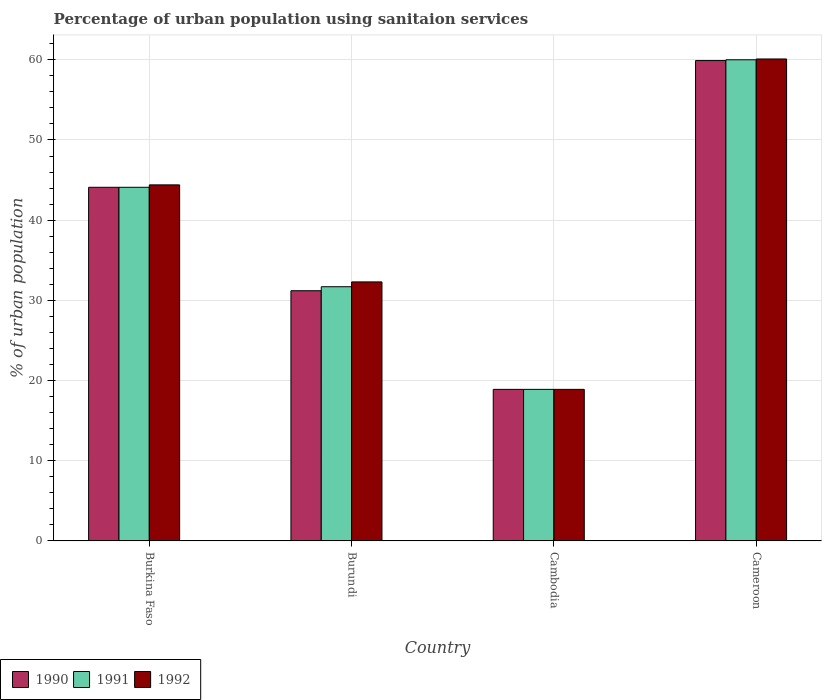Are the number of bars per tick equal to the number of legend labels?
Ensure brevity in your answer.  Yes. Are the number of bars on each tick of the X-axis equal?
Provide a short and direct response. Yes. How many bars are there on the 1st tick from the left?
Ensure brevity in your answer.  3. What is the label of the 1st group of bars from the left?
Your response must be concise. Burkina Faso. In how many cases, is the number of bars for a given country not equal to the number of legend labels?
Make the answer very short. 0. What is the percentage of urban population using sanitaion services in 1991 in Cameroon?
Your answer should be very brief. 60. Across all countries, what is the maximum percentage of urban population using sanitaion services in 1990?
Provide a succinct answer. 59.9. Across all countries, what is the minimum percentage of urban population using sanitaion services in 1990?
Offer a very short reply. 18.9. In which country was the percentage of urban population using sanitaion services in 1991 maximum?
Offer a very short reply. Cameroon. In which country was the percentage of urban population using sanitaion services in 1991 minimum?
Make the answer very short. Cambodia. What is the total percentage of urban population using sanitaion services in 1992 in the graph?
Ensure brevity in your answer.  155.7. What is the difference between the percentage of urban population using sanitaion services in 1992 in Burkina Faso and that in Cameroon?
Your answer should be very brief. -15.7. What is the difference between the percentage of urban population using sanitaion services in 1992 in Cameroon and the percentage of urban population using sanitaion services in 1990 in Burundi?
Offer a very short reply. 28.9. What is the average percentage of urban population using sanitaion services in 1990 per country?
Your answer should be very brief. 38.52. What is the difference between the percentage of urban population using sanitaion services of/in 1991 and percentage of urban population using sanitaion services of/in 1992 in Cambodia?
Offer a terse response. 0. What is the ratio of the percentage of urban population using sanitaion services in 1990 in Burkina Faso to that in Cambodia?
Your response must be concise. 2.33. Is the percentage of urban population using sanitaion services in 1991 in Burkina Faso less than that in Burundi?
Your response must be concise. No. What is the difference between the highest and the second highest percentage of urban population using sanitaion services in 1991?
Ensure brevity in your answer.  15.9. What is the difference between the highest and the lowest percentage of urban population using sanitaion services in 1991?
Your answer should be compact. 41.1. Is the sum of the percentage of urban population using sanitaion services in 1991 in Burkina Faso and Cambodia greater than the maximum percentage of urban population using sanitaion services in 1992 across all countries?
Provide a short and direct response. Yes. What does the 3rd bar from the left in Burkina Faso represents?
Your response must be concise. 1992. How many bars are there?
Offer a very short reply. 12. How many countries are there in the graph?
Offer a very short reply. 4. Are the values on the major ticks of Y-axis written in scientific E-notation?
Offer a very short reply. No. Does the graph contain any zero values?
Ensure brevity in your answer.  No. Does the graph contain grids?
Your answer should be compact. Yes. How many legend labels are there?
Keep it short and to the point. 3. How are the legend labels stacked?
Give a very brief answer. Horizontal. What is the title of the graph?
Keep it short and to the point. Percentage of urban population using sanitaion services. What is the label or title of the Y-axis?
Make the answer very short. % of urban population. What is the % of urban population in 1990 in Burkina Faso?
Ensure brevity in your answer.  44.1. What is the % of urban population in 1991 in Burkina Faso?
Your answer should be very brief. 44.1. What is the % of urban population of 1992 in Burkina Faso?
Provide a succinct answer. 44.4. What is the % of urban population of 1990 in Burundi?
Provide a succinct answer. 31.2. What is the % of urban population in 1991 in Burundi?
Make the answer very short. 31.7. What is the % of urban population of 1992 in Burundi?
Provide a succinct answer. 32.3. What is the % of urban population of 1990 in Cameroon?
Ensure brevity in your answer.  59.9. What is the % of urban population in 1992 in Cameroon?
Offer a terse response. 60.1. Across all countries, what is the maximum % of urban population of 1990?
Keep it short and to the point. 59.9. Across all countries, what is the maximum % of urban population in 1991?
Your response must be concise. 60. Across all countries, what is the maximum % of urban population of 1992?
Your answer should be very brief. 60.1. Across all countries, what is the minimum % of urban population of 1990?
Provide a succinct answer. 18.9. Across all countries, what is the minimum % of urban population in 1992?
Keep it short and to the point. 18.9. What is the total % of urban population in 1990 in the graph?
Ensure brevity in your answer.  154.1. What is the total % of urban population of 1991 in the graph?
Give a very brief answer. 154.7. What is the total % of urban population of 1992 in the graph?
Keep it short and to the point. 155.7. What is the difference between the % of urban population in 1990 in Burkina Faso and that in Burundi?
Offer a very short reply. 12.9. What is the difference between the % of urban population in 1991 in Burkina Faso and that in Burundi?
Give a very brief answer. 12.4. What is the difference between the % of urban population of 1992 in Burkina Faso and that in Burundi?
Your answer should be very brief. 12.1. What is the difference between the % of urban population of 1990 in Burkina Faso and that in Cambodia?
Ensure brevity in your answer.  25.2. What is the difference between the % of urban population in 1991 in Burkina Faso and that in Cambodia?
Ensure brevity in your answer.  25.2. What is the difference between the % of urban population of 1992 in Burkina Faso and that in Cambodia?
Make the answer very short. 25.5. What is the difference between the % of urban population in 1990 in Burkina Faso and that in Cameroon?
Ensure brevity in your answer.  -15.8. What is the difference between the % of urban population in 1991 in Burkina Faso and that in Cameroon?
Provide a short and direct response. -15.9. What is the difference between the % of urban population in 1992 in Burkina Faso and that in Cameroon?
Make the answer very short. -15.7. What is the difference between the % of urban population of 1990 in Burundi and that in Cameroon?
Provide a succinct answer. -28.7. What is the difference between the % of urban population in 1991 in Burundi and that in Cameroon?
Your response must be concise. -28.3. What is the difference between the % of urban population of 1992 in Burundi and that in Cameroon?
Ensure brevity in your answer.  -27.8. What is the difference between the % of urban population in 1990 in Cambodia and that in Cameroon?
Offer a very short reply. -41. What is the difference between the % of urban population in 1991 in Cambodia and that in Cameroon?
Provide a succinct answer. -41.1. What is the difference between the % of urban population of 1992 in Cambodia and that in Cameroon?
Your answer should be very brief. -41.2. What is the difference between the % of urban population in 1990 in Burkina Faso and the % of urban population in 1991 in Burundi?
Offer a very short reply. 12.4. What is the difference between the % of urban population in 1990 in Burkina Faso and the % of urban population in 1991 in Cambodia?
Give a very brief answer. 25.2. What is the difference between the % of urban population of 1990 in Burkina Faso and the % of urban population of 1992 in Cambodia?
Provide a succinct answer. 25.2. What is the difference between the % of urban population in 1991 in Burkina Faso and the % of urban population in 1992 in Cambodia?
Offer a very short reply. 25.2. What is the difference between the % of urban population of 1990 in Burkina Faso and the % of urban population of 1991 in Cameroon?
Provide a short and direct response. -15.9. What is the difference between the % of urban population in 1990 in Burkina Faso and the % of urban population in 1992 in Cameroon?
Offer a very short reply. -16. What is the difference between the % of urban population in 1990 in Burundi and the % of urban population in 1991 in Cambodia?
Offer a very short reply. 12.3. What is the difference between the % of urban population of 1991 in Burundi and the % of urban population of 1992 in Cambodia?
Your response must be concise. 12.8. What is the difference between the % of urban population in 1990 in Burundi and the % of urban population in 1991 in Cameroon?
Your answer should be compact. -28.8. What is the difference between the % of urban population of 1990 in Burundi and the % of urban population of 1992 in Cameroon?
Keep it short and to the point. -28.9. What is the difference between the % of urban population in 1991 in Burundi and the % of urban population in 1992 in Cameroon?
Your answer should be very brief. -28.4. What is the difference between the % of urban population in 1990 in Cambodia and the % of urban population in 1991 in Cameroon?
Make the answer very short. -41.1. What is the difference between the % of urban population of 1990 in Cambodia and the % of urban population of 1992 in Cameroon?
Your response must be concise. -41.2. What is the difference between the % of urban population of 1991 in Cambodia and the % of urban population of 1992 in Cameroon?
Offer a terse response. -41.2. What is the average % of urban population in 1990 per country?
Your answer should be very brief. 38.52. What is the average % of urban population of 1991 per country?
Offer a very short reply. 38.67. What is the average % of urban population of 1992 per country?
Offer a very short reply. 38.92. What is the difference between the % of urban population of 1990 and % of urban population of 1991 in Burundi?
Offer a very short reply. -0.5. What is the difference between the % of urban population in 1990 and % of urban population in 1992 in Burundi?
Offer a very short reply. -1.1. What is the difference between the % of urban population of 1990 and % of urban population of 1991 in Cameroon?
Keep it short and to the point. -0.1. What is the difference between the % of urban population of 1990 and % of urban population of 1992 in Cameroon?
Your answer should be very brief. -0.2. What is the difference between the % of urban population in 1991 and % of urban population in 1992 in Cameroon?
Your response must be concise. -0.1. What is the ratio of the % of urban population of 1990 in Burkina Faso to that in Burundi?
Give a very brief answer. 1.41. What is the ratio of the % of urban population in 1991 in Burkina Faso to that in Burundi?
Your answer should be very brief. 1.39. What is the ratio of the % of urban population in 1992 in Burkina Faso to that in Burundi?
Provide a succinct answer. 1.37. What is the ratio of the % of urban population of 1990 in Burkina Faso to that in Cambodia?
Provide a succinct answer. 2.33. What is the ratio of the % of urban population of 1991 in Burkina Faso to that in Cambodia?
Ensure brevity in your answer.  2.33. What is the ratio of the % of urban population of 1992 in Burkina Faso to that in Cambodia?
Offer a very short reply. 2.35. What is the ratio of the % of urban population in 1990 in Burkina Faso to that in Cameroon?
Give a very brief answer. 0.74. What is the ratio of the % of urban population in 1991 in Burkina Faso to that in Cameroon?
Your answer should be compact. 0.73. What is the ratio of the % of urban population of 1992 in Burkina Faso to that in Cameroon?
Offer a very short reply. 0.74. What is the ratio of the % of urban population in 1990 in Burundi to that in Cambodia?
Provide a short and direct response. 1.65. What is the ratio of the % of urban population of 1991 in Burundi to that in Cambodia?
Your response must be concise. 1.68. What is the ratio of the % of urban population in 1992 in Burundi to that in Cambodia?
Provide a succinct answer. 1.71. What is the ratio of the % of urban population in 1990 in Burundi to that in Cameroon?
Keep it short and to the point. 0.52. What is the ratio of the % of urban population in 1991 in Burundi to that in Cameroon?
Provide a short and direct response. 0.53. What is the ratio of the % of urban population of 1992 in Burundi to that in Cameroon?
Give a very brief answer. 0.54. What is the ratio of the % of urban population in 1990 in Cambodia to that in Cameroon?
Your answer should be compact. 0.32. What is the ratio of the % of urban population of 1991 in Cambodia to that in Cameroon?
Ensure brevity in your answer.  0.32. What is the ratio of the % of urban population in 1992 in Cambodia to that in Cameroon?
Ensure brevity in your answer.  0.31. What is the difference between the highest and the second highest % of urban population of 1990?
Offer a very short reply. 15.8. What is the difference between the highest and the second highest % of urban population of 1991?
Offer a very short reply. 15.9. What is the difference between the highest and the lowest % of urban population in 1990?
Give a very brief answer. 41. What is the difference between the highest and the lowest % of urban population of 1991?
Give a very brief answer. 41.1. What is the difference between the highest and the lowest % of urban population in 1992?
Ensure brevity in your answer.  41.2. 